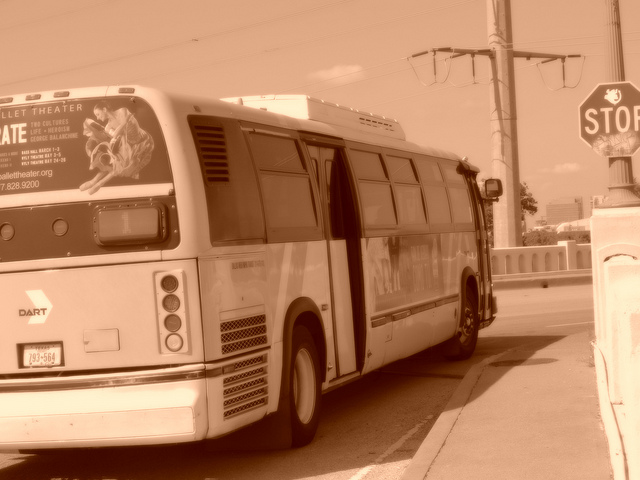Identify the text displayed in this image. LLET THEATER ATE 9200 564 DART 